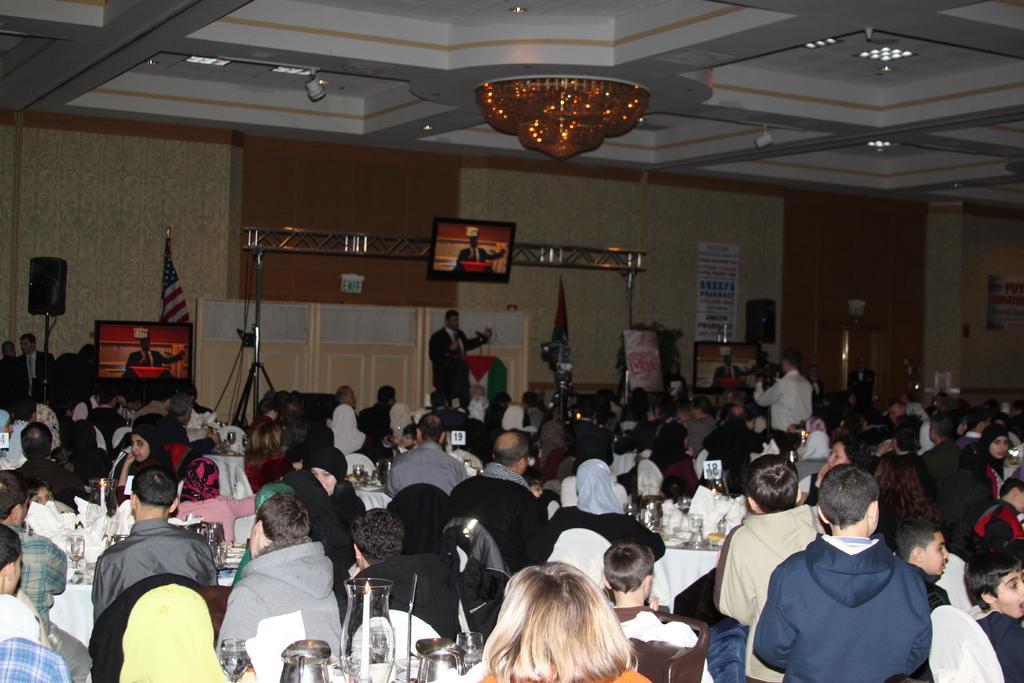Please provide a concise description of this image. In this image there are group of persons sitting and standing. In the background there are flags and there are tv´s and there is a person standing and speaking. On the right side there is a man standing and taking a video holding a camera. In the front on the table there are glasses, there is a jar. In the background on the right side there are posters on the wall with some text written on it, and there are speakers. 